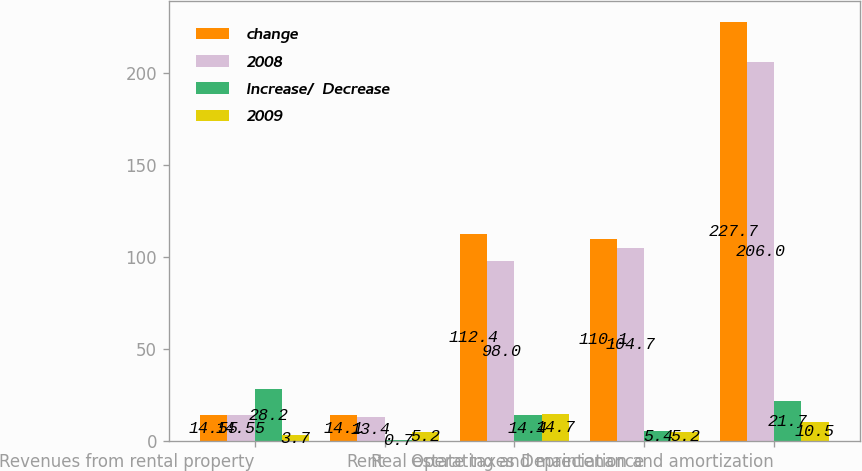Convert chart. <chart><loc_0><loc_0><loc_500><loc_500><stacked_bar_chart><ecel><fcel>Revenues from rental property<fcel>Rent<fcel>Real estate taxes<fcel>Operating and maintenance<fcel>Depreciation and amortization<nl><fcel>change<fcel>14.55<fcel>14.1<fcel>112.4<fcel>110.1<fcel>227.7<nl><fcel>2008<fcel>14.55<fcel>13.4<fcel>98<fcel>104.7<fcel>206<nl><fcel>Increase/  Decrease<fcel>28.2<fcel>0.7<fcel>14.4<fcel>5.4<fcel>21.7<nl><fcel>2009<fcel>3.7<fcel>5.2<fcel>14.7<fcel>5.2<fcel>10.5<nl></chart> 